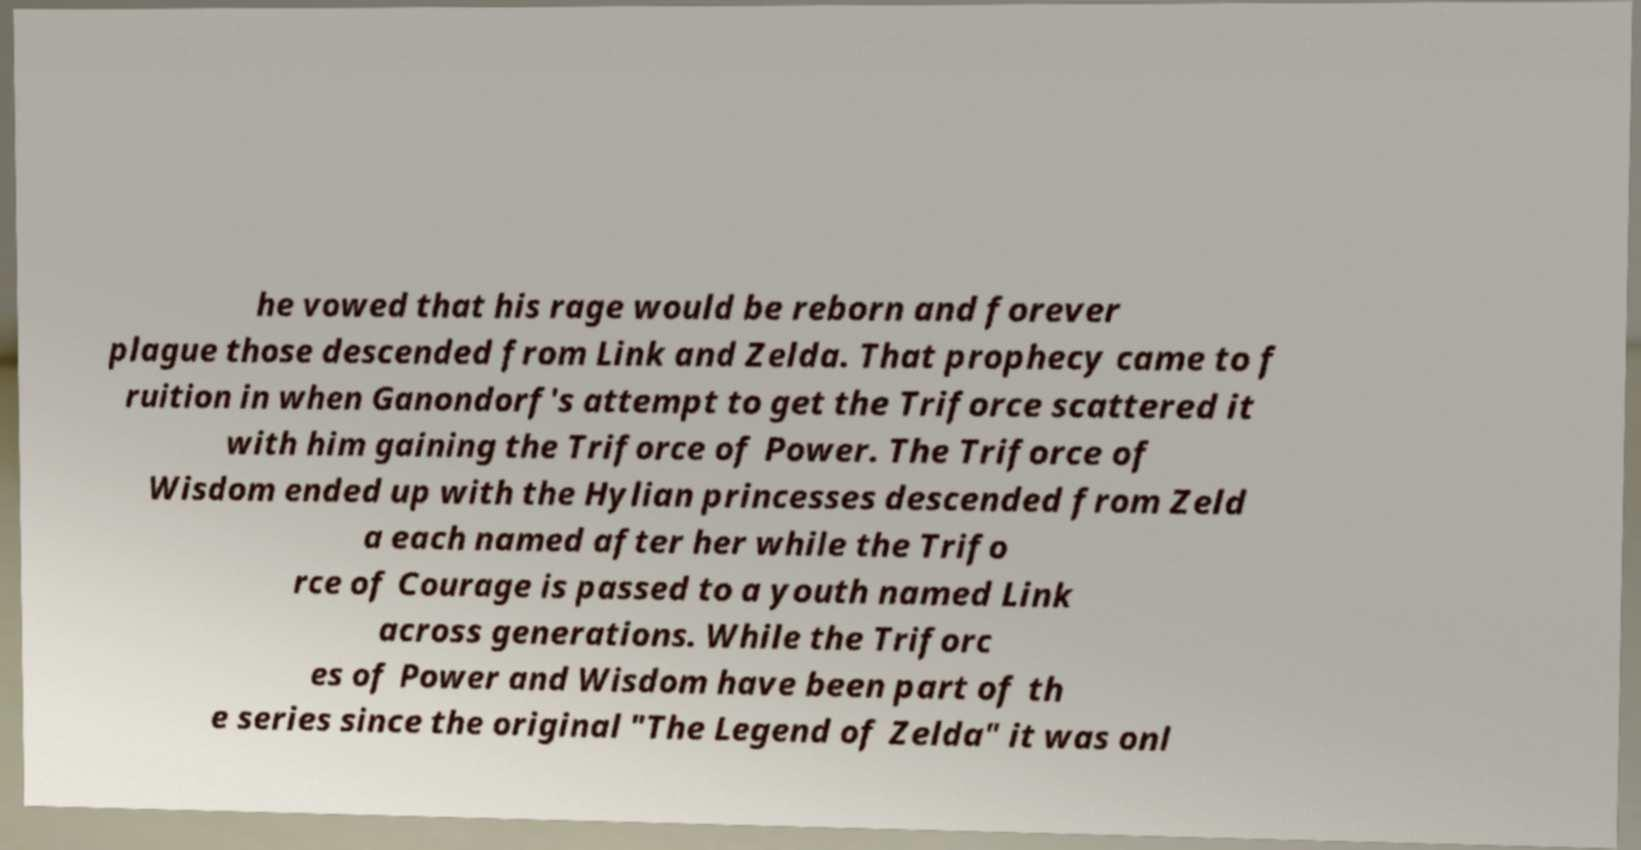What messages or text are displayed in this image? I need them in a readable, typed format. he vowed that his rage would be reborn and forever plague those descended from Link and Zelda. That prophecy came to f ruition in when Ganondorf's attempt to get the Triforce scattered it with him gaining the Triforce of Power. The Triforce of Wisdom ended up with the Hylian princesses descended from Zeld a each named after her while the Trifo rce of Courage is passed to a youth named Link across generations. While the Triforc es of Power and Wisdom have been part of th e series since the original "The Legend of Zelda" it was onl 